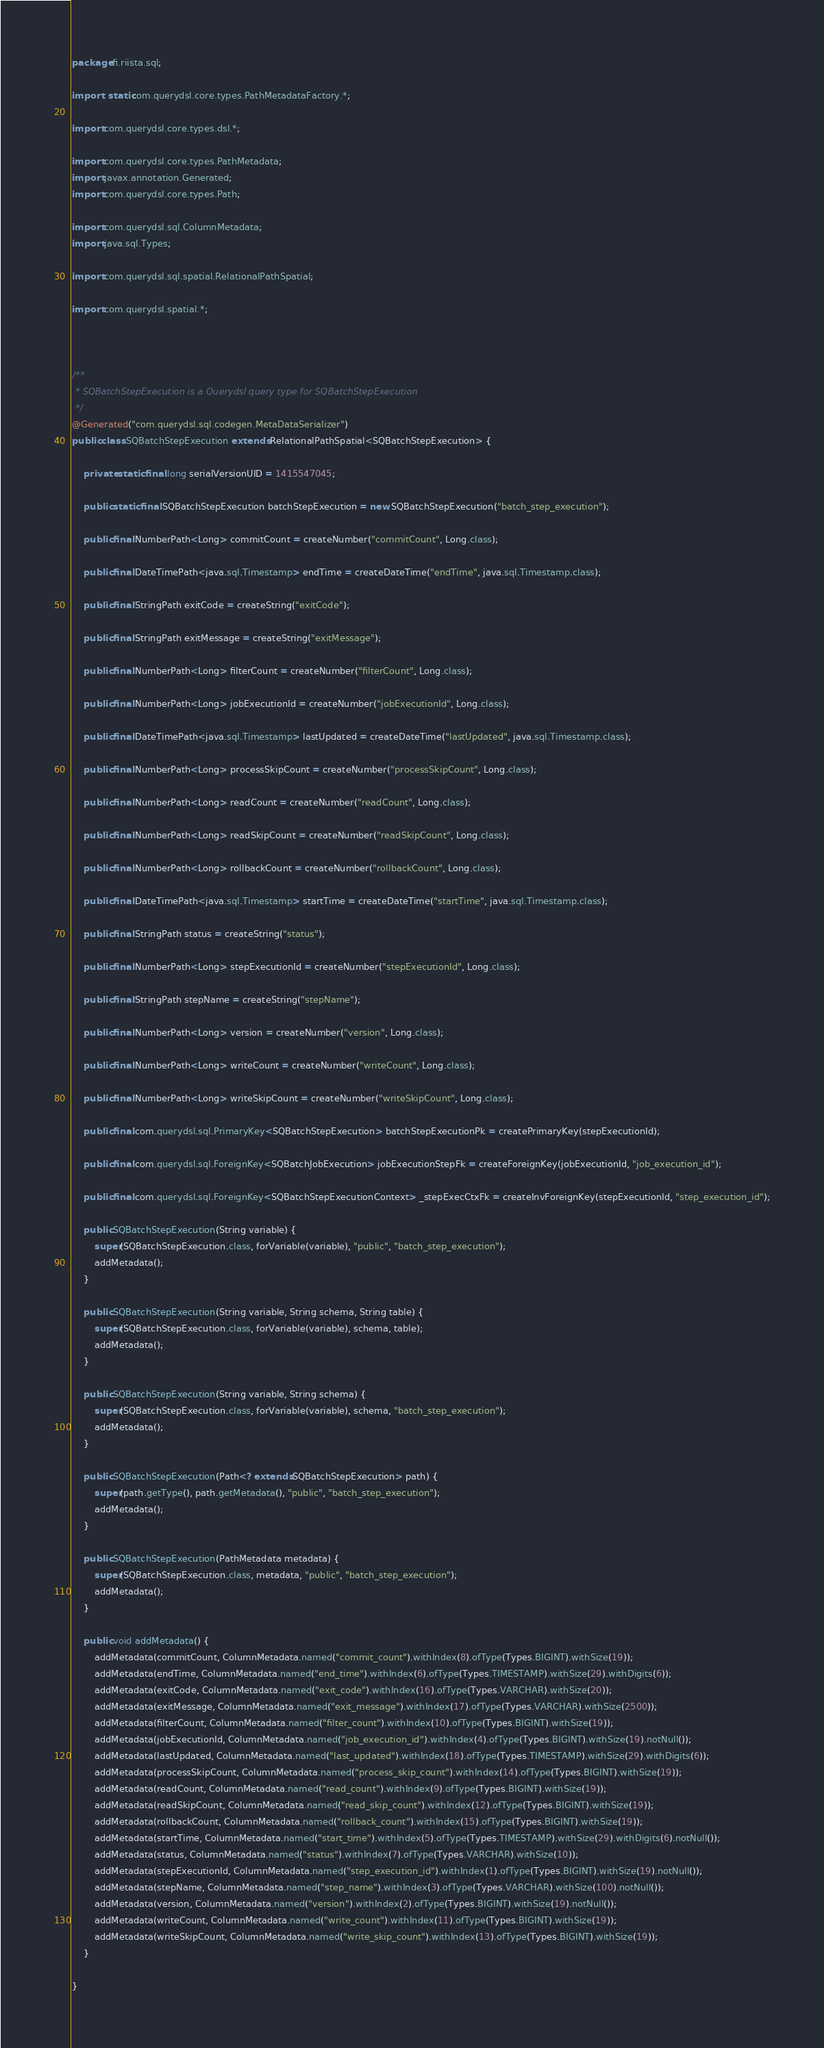Convert code to text. <code><loc_0><loc_0><loc_500><loc_500><_Java_>package fi.riista.sql;

import static com.querydsl.core.types.PathMetadataFactory.*;

import com.querydsl.core.types.dsl.*;

import com.querydsl.core.types.PathMetadata;
import javax.annotation.Generated;
import com.querydsl.core.types.Path;

import com.querydsl.sql.ColumnMetadata;
import java.sql.Types;

import com.querydsl.sql.spatial.RelationalPathSpatial;

import com.querydsl.spatial.*;



/**
 * SQBatchStepExecution is a Querydsl query type for SQBatchStepExecution
 */
@Generated("com.querydsl.sql.codegen.MetaDataSerializer")
public class SQBatchStepExecution extends RelationalPathSpatial<SQBatchStepExecution> {

    private static final long serialVersionUID = 1415547045;

    public static final SQBatchStepExecution batchStepExecution = new SQBatchStepExecution("batch_step_execution");

    public final NumberPath<Long> commitCount = createNumber("commitCount", Long.class);

    public final DateTimePath<java.sql.Timestamp> endTime = createDateTime("endTime", java.sql.Timestamp.class);

    public final StringPath exitCode = createString("exitCode");

    public final StringPath exitMessage = createString("exitMessage");

    public final NumberPath<Long> filterCount = createNumber("filterCount", Long.class);

    public final NumberPath<Long> jobExecutionId = createNumber("jobExecutionId", Long.class);

    public final DateTimePath<java.sql.Timestamp> lastUpdated = createDateTime("lastUpdated", java.sql.Timestamp.class);

    public final NumberPath<Long> processSkipCount = createNumber("processSkipCount", Long.class);

    public final NumberPath<Long> readCount = createNumber("readCount", Long.class);

    public final NumberPath<Long> readSkipCount = createNumber("readSkipCount", Long.class);

    public final NumberPath<Long> rollbackCount = createNumber("rollbackCount", Long.class);

    public final DateTimePath<java.sql.Timestamp> startTime = createDateTime("startTime", java.sql.Timestamp.class);

    public final StringPath status = createString("status");

    public final NumberPath<Long> stepExecutionId = createNumber("stepExecutionId", Long.class);

    public final StringPath stepName = createString("stepName");

    public final NumberPath<Long> version = createNumber("version", Long.class);

    public final NumberPath<Long> writeCount = createNumber("writeCount", Long.class);

    public final NumberPath<Long> writeSkipCount = createNumber("writeSkipCount", Long.class);

    public final com.querydsl.sql.PrimaryKey<SQBatchStepExecution> batchStepExecutionPk = createPrimaryKey(stepExecutionId);

    public final com.querydsl.sql.ForeignKey<SQBatchJobExecution> jobExecutionStepFk = createForeignKey(jobExecutionId, "job_execution_id");

    public final com.querydsl.sql.ForeignKey<SQBatchStepExecutionContext> _stepExecCtxFk = createInvForeignKey(stepExecutionId, "step_execution_id");

    public SQBatchStepExecution(String variable) {
        super(SQBatchStepExecution.class, forVariable(variable), "public", "batch_step_execution");
        addMetadata();
    }

    public SQBatchStepExecution(String variable, String schema, String table) {
        super(SQBatchStepExecution.class, forVariable(variable), schema, table);
        addMetadata();
    }

    public SQBatchStepExecution(String variable, String schema) {
        super(SQBatchStepExecution.class, forVariable(variable), schema, "batch_step_execution");
        addMetadata();
    }

    public SQBatchStepExecution(Path<? extends SQBatchStepExecution> path) {
        super(path.getType(), path.getMetadata(), "public", "batch_step_execution");
        addMetadata();
    }

    public SQBatchStepExecution(PathMetadata metadata) {
        super(SQBatchStepExecution.class, metadata, "public", "batch_step_execution");
        addMetadata();
    }

    public void addMetadata() {
        addMetadata(commitCount, ColumnMetadata.named("commit_count").withIndex(8).ofType(Types.BIGINT).withSize(19));
        addMetadata(endTime, ColumnMetadata.named("end_time").withIndex(6).ofType(Types.TIMESTAMP).withSize(29).withDigits(6));
        addMetadata(exitCode, ColumnMetadata.named("exit_code").withIndex(16).ofType(Types.VARCHAR).withSize(20));
        addMetadata(exitMessage, ColumnMetadata.named("exit_message").withIndex(17).ofType(Types.VARCHAR).withSize(2500));
        addMetadata(filterCount, ColumnMetadata.named("filter_count").withIndex(10).ofType(Types.BIGINT).withSize(19));
        addMetadata(jobExecutionId, ColumnMetadata.named("job_execution_id").withIndex(4).ofType(Types.BIGINT).withSize(19).notNull());
        addMetadata(lastUpdated, ColumnMetadata.named("last_updated").withIndex(18).ofType(Types.TIMESTAMP).withSize(29).withDigits(6));
        addMetadata(processSkipCount, ColumnMetadata.named("process_skip_count").withIndex(14).ofType(Types.BIGINT).withSize(19));
        addMetadata(readCount, ColumnMetadata.named("read_count").withIndex(9).ofType(Types.BIGINT).withSize(19));
        addMetadata(readSkipCount, ColumnMetadata.named("read_skip_count").withIndex(12).ofType(Types.BIGINT).withSize(19));
        addMetadata(rollbackCount, ColumnMetadata.named("rollback_count").withIndex(15).ofType(Types.BIGINT).withSize(19));
        addMetadata(startTime, ColumnMetadata.named("start_time").withIndex(5).ofType(Types.TIMESTAMP).withSize(29).withDigits(6).notNull());
        addMetadata(status, ColumnMetadata.named("status").withIndex(7).ofType(Types.VARCHAR).withSize(10));
        addMetadata(stepExecutionId, ColumnMetadata.named("step_execution_id").withIndex(1).ofType(Types.BIGINT).withSize(19).notNull());
        addMetadata(stepName, ColumnMetadata.named("step_name").withIndex(3).ofType(Types.VARCHAR).withSize(100).notNull());
        addMetadata(version, ColumnMetadata.named("version").withIndex(2).ofType(Types.BIGINT).withSize(19).notNull());
        addMetadata(writeCount, ColumnMetadata.named("write_count").withIndex(11).ofType(Types.BIGINT).withSize(19));
        addMetadata(writeSkipCount, ColumnMetadata.named("write_skip_count").withIndex(13).ofType(Types.BIGINT).withSize(19));
    }

}

</code> 